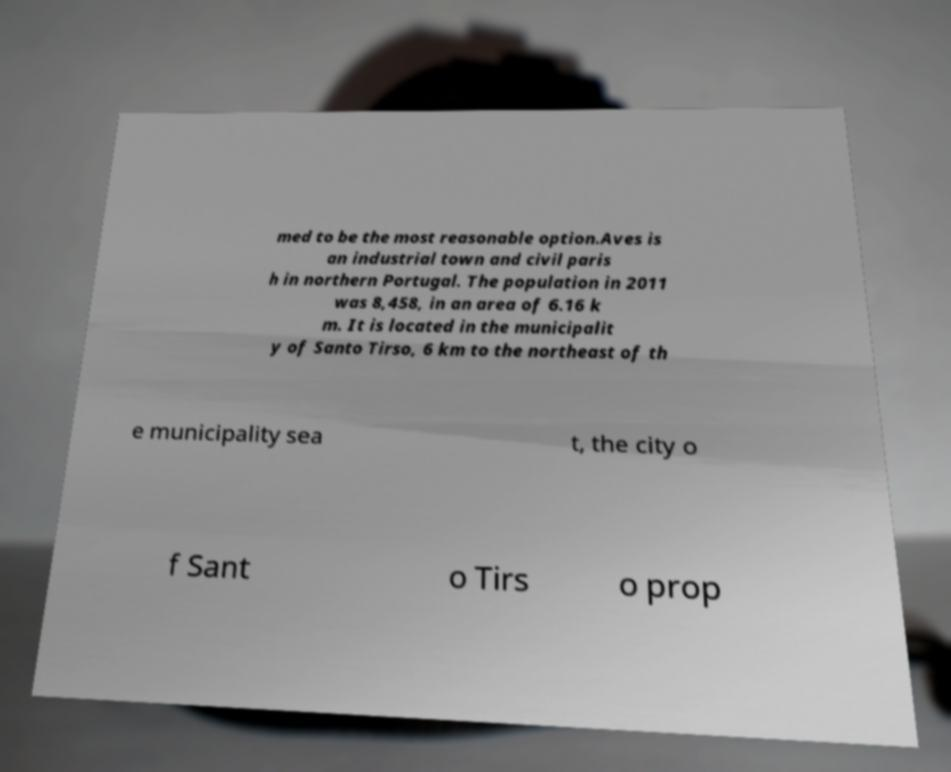Please identify and transcribe the text found in this image. med to be the most reasonable option.Aves is an industrial town and civil paris h in northern Portugal. The population in 2011 was 8,458, in an area of 6.16 k m. It is located in the municipalit y of Santo Tirso, 6 km to the northeast of th e municipality sea t, the city o f Sant o Tirs o prop 